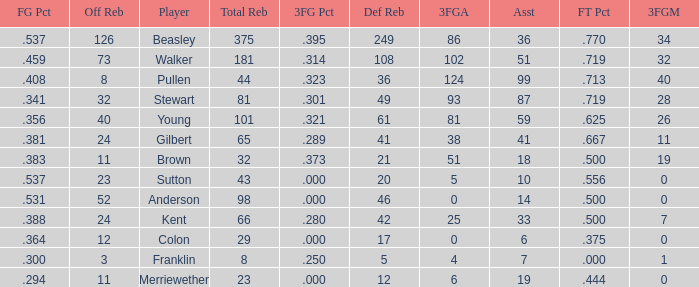What is the total number of offensive rebounds for players with more than 124 3-point attempts? 0.0. 